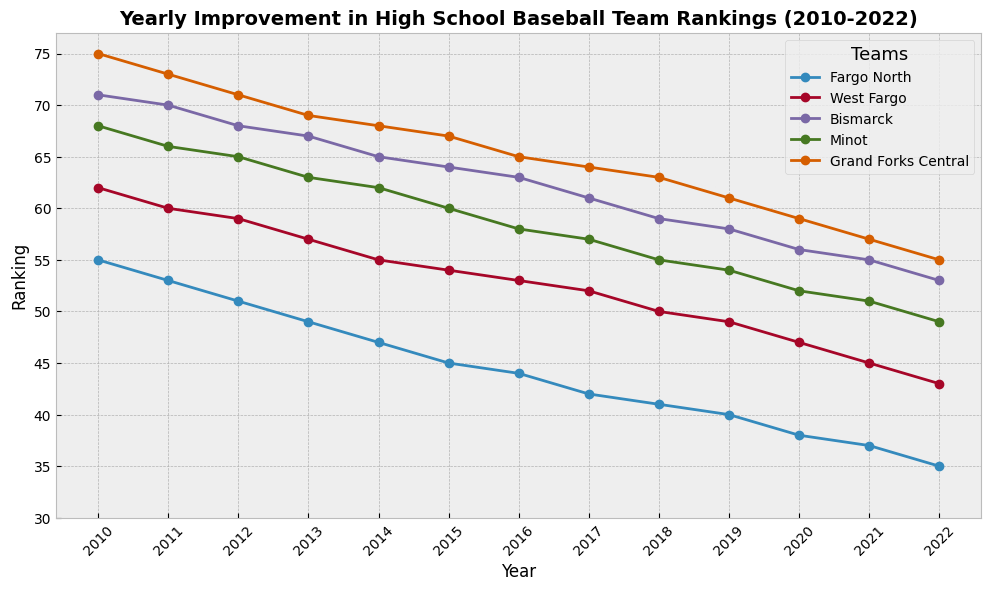What was the ranking of Fargo North in 2021? Look at the line representing Fargo North and find the point corresponding to the year 2021. The ranking is labeled next to this point.
Answer: 37 Which team showed the greatest improvement in rankings from 2010 to 2022? Compare the rankings of each team in 2010 and 2022. Fargo North improved from 55 in 2010 to 35 in 2022, an improvement of 20 ranks, which is the greatest improvement among the teams.
Answer: Fargo North Between Minot and Grand Forks Central, which team had a higher ranking in 2014? Find the points representing Minot and Grand Forks Central in 2014 and compare their rankings. Minot has a ranking of 62, and Grand Forks Central has a ranking of 68.
Answer: Minot What is the average ranking of West Fargo in 2019 and 2020? Add the rankings of West Fargo for 2019 (49) and 2020 (47), then divide by 2. (49 + 47) / 2 = 96 / 2 = 48.
Answer: 48 How did the rankings of Bismarck change between 2013 and 2016? Look at the line representing Bismarck and note the rankings at 2013 (67) and 2016 (63). Calculate the difference: 67 - 63 = 4, showing a decrease in ranking by 4.
Answer: Decreased by 4 Which team had the smallest change in ranking between 2010 and 2022? Calculate the difference in rankings for each team between 2010 and 2022. Minot changed from 68 in 2010 to 49 in 2022, a difference of 19, which is the smallest change among the teams.
Answer: Minot In which year did Fargo North first achieve a ranking of less than 40? Identify the year in which Fargo North's ranking dropped below 40 by following the Fargo North line and noting the year of the first data point below 40. This occurred in 2020.
Answer: 2020 Compare the rankings of all teams in 2016. Which team had the highest ranking and which had the lowest? Look at the 2016 rankings for all teams: Fargo North (44), West Fargo (53), Bismarck (63), Minot (58), and Grand Forks Central (65). The highest ranking is Fargo North at 44, and the lowest ranking is Grand Forks Central at 65.
Answer: Highest: Fargo North, Lowest: Grand Forks Central What's the median ranking for Minot over the given years? List Minot's rankings: 68, 66, 65, 63, 62, 60, 58, 57, 55, 54, 52, 51, 49. The median value, the middle number in this ordered list, is 60.
Answer: 60 Which team consistently improved their ranking every year without any drops? Examine each team's ranking changes year by year. Fargo North is the only team whose ranking improved consistently every year without any drops.
Answer: Fargo North 